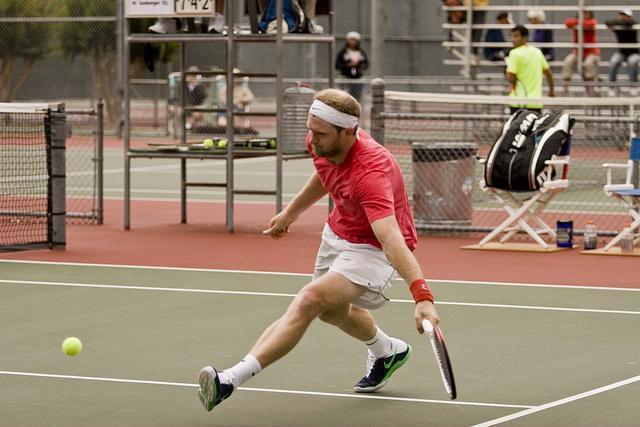How many people are there?
Give a very brief answer. 3. How many red suitcases are there?
Give a very brief answer. 0. 